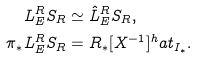Convert formula to latex. <formula><loc_0><loc_0><loc_500><loc_500>L ^ { R } _ { E } S _ { R } & \simeq \hat { L } ^ { R } _ { E } S _ { R } , \\ \pi _ { * } L ^ { R } _ { E } S _ { R } & = R _ { * } [ X ^ { - 1 } ] ^ { h } a t _ { I _ { * } } .</formula> 